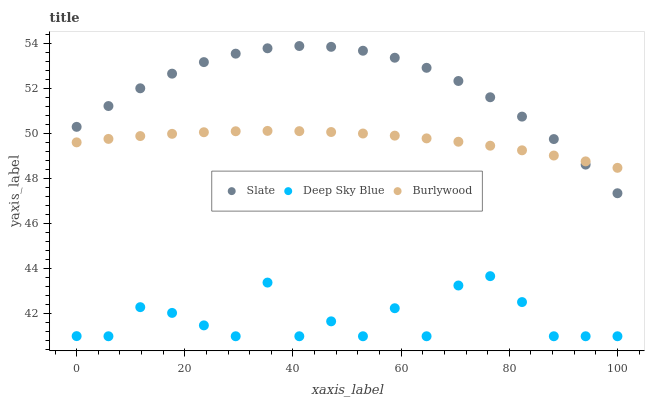Does Deep Sky Blue have the minimum area under the curve?
Answer yes or no. Yes. Does Slate have the maximum area under the curve?
Answer yes or no. Yes. Does Slate have the minimum area under the curve?
Answer yes or no. No. Does Deep Sky Blue have the maximum area under the curve?
Answer yes or no. No. Is Burlywood the smoothest?
Answer yes or no. Yes. Is Deep Sky Blue the roughest?
Answer yes or no. Yes. Is Slate the smoothest?
Answer yes or no. No. Is Slate the roughest?
Answer yes or no. No. Does Deep Sky Blue have the lowest value?
Answer yes or no. Yes. Does Slate have the lowest value?
Answer yes or no. No. Does Slate have the highest value?
Answer yes or no. Yes. Does Deep Sky Blue have the highest value?
Answer yes or no. No. Is Deep Sky Blue less than Slate?
Answer yes or no. Yes. Is Slate greater than Deep Sky Blue?
Answer yes or no. Yes. Does Slate intersect Burlywood?
Answer yes or no. Yes. Is Slate less than Burlywood?
Answer yes or no. No. Is Slate greater than Burlywood?
Answer yes or no. No. Does Deep Sky Blue intersect Slate?
Answer yes or no. No. 